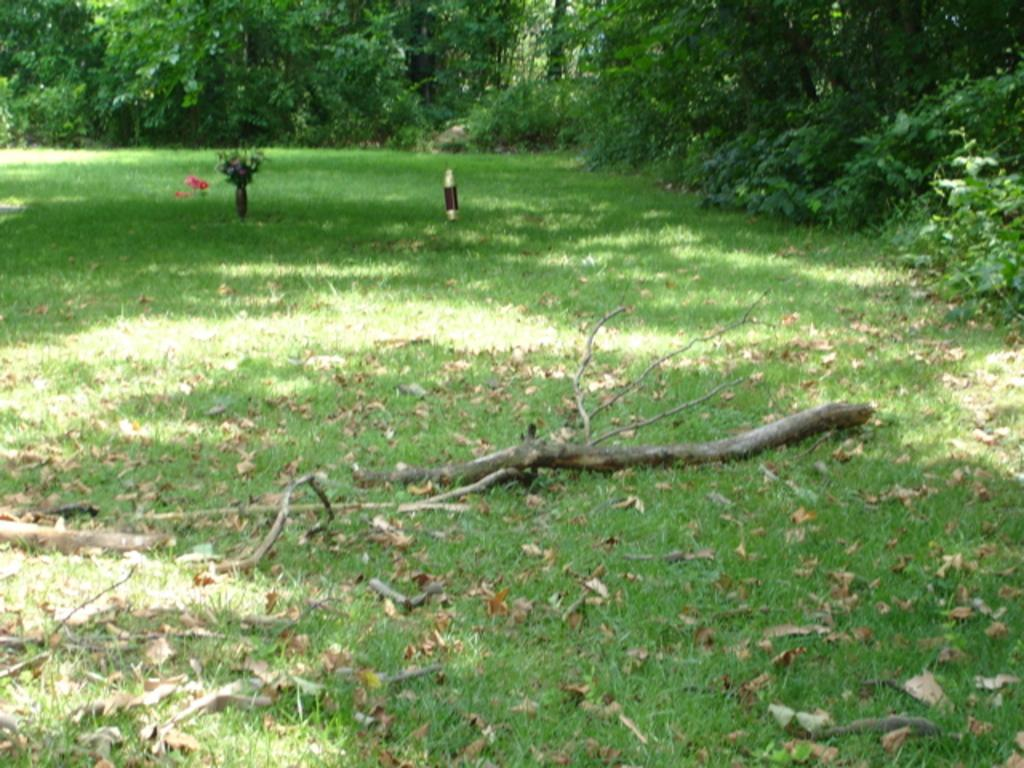What type of vegetation is visible in the image? There is grass in the image. What objects are placed on the ground in the image? There are flower vases on the ground in the image. What can be seen in the background of the image? There are trees in the background of the image. What type of metal is being used for the feast in the image? There is no feast present in the image, and therefore no metal is being used for it. 